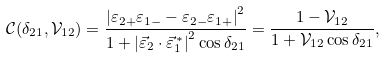Convert formula to latex. <formula><loc_0><loc_0><loc_500><loc_500>\mathcal { C } ( \delta _ { 2 1 } , \mathcal { V } _ { 1 2 } ) = \frac { \left | \varepsilon _ { 2 + } \varepsilon _ { 1 - } - \varepsilon _ { 2 - } \varepsilon _ { 1 + } \right | ^ { 2 } } { 1 + \left | \vec { \varepsilon } _ { 2 } \cdot \vec { \varepsilon } ^ { \, * } _ { 1 } \right | ^ { 2 } \cos \delta _ { 2 1 } } = \frac { 1 - \mathcal { V } _ { 1 2 } } { 1 + \mathcal { V } _ { 1 2 } \cos \delta _ { 2 1 } } ,</formula> 